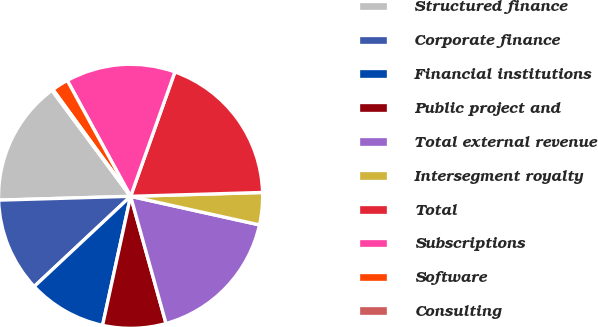Convert chart to OTSL. <chart><loc_0><loc_0><loc_500><loc_500><pie_chart><fcel>Structured finance<fcel>Corporate finance<fcel>Financial institutions<fcel>Public project and<fcel>Total external revenue<fcel>Intersegment royalty<fcel>Total<fcel>Subscriptions<fcel>Software<fcel>Consulting<nl><fcel>15.3%<fcel>11.51%<fcel>9.62%<fcel>7.73%<fcel>17.2%<fcel>3.94%<fcel>19.09%<fcel>13.41%<fcel>2.05%<fcel>0.15%<nl></chart> 